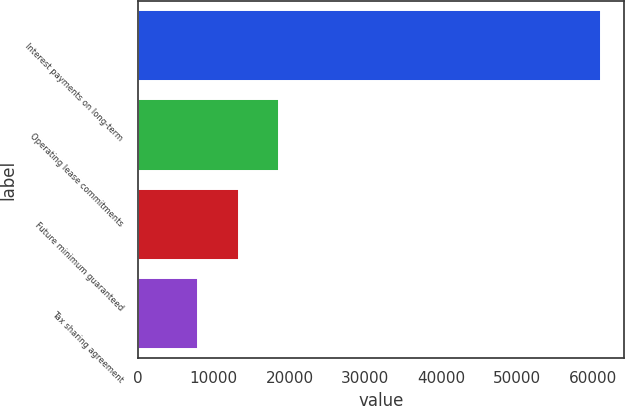<chart> <loc_0><loc_0><loc_500><loc_500><bar_chart><fcel>Interest payments on long-term<fcel>Operating lease commitments<fcel>Future minimum guaranteed<fcel>Tax sharing agreement<nl><fcel>61053<fcel>18610.6<fcel>13305.3<fcel>8000<nl></chart> 